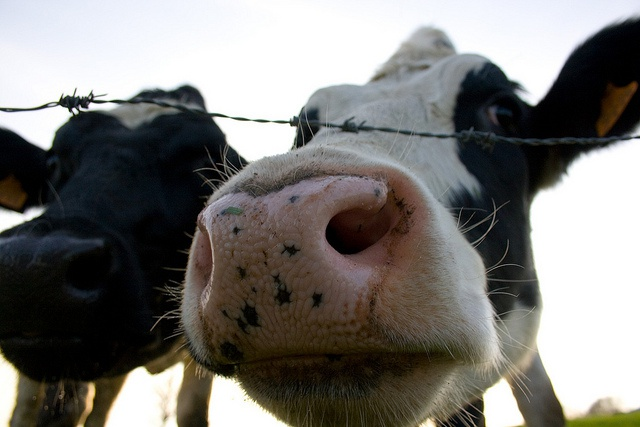Describe the objects in this image and their specific colors. I can see cow in lavender, black, gray, and darkgray tones and cow in lavender, black, olive, and gray tones in this image. 